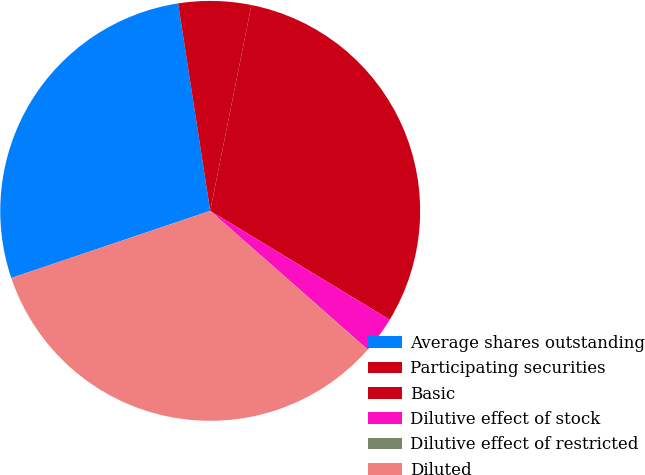<chart> <loc_0><loc_0><loc_500><loc_500><pie_chart><fcel>Average shares outstanding<fcel>Participating securities<fcel>Basic<fcel>Dilutive effect of stock<fcel>Dilutive effect of restricted<fcel>Diluted<nl><fcel>27.74%<fcel>5.59%<fcel>30.53%<fcel>2.81%<fcel>0.02%<fcel>33.31%<nl></chart> 